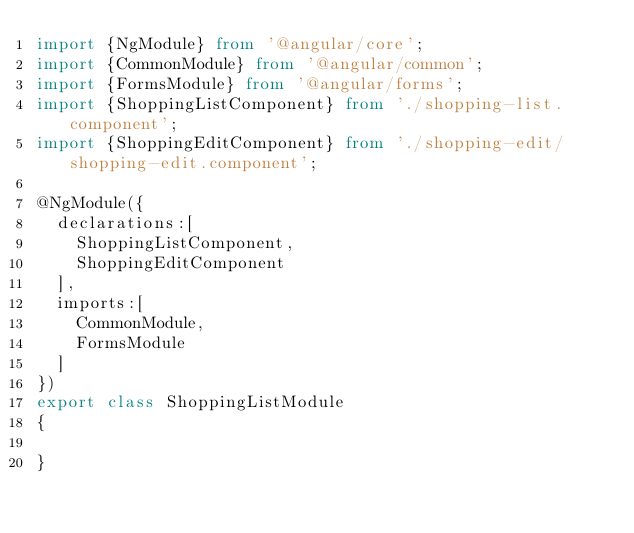<code> <loc_0><loc_0><loc_500><loc_500><_TypeScript_>import {NgModule} from '@angular/core';
import {CommonModule} from '@angular/common';
import {FormsModule} from '@angular/forms';
import {ShoppingListComponent} from './shopping-list.component';
import {ShoppingEditComponent} from './shopping-edit/shopping-edit.component';

@NgModule({
	declarations:[
		ShoppingListComponent,
		ShoppingEditComponent
	],
	imports:[
		CommonModule,
		FormsModule
	]
})
export class ShoppingListModule
{

}</code> 